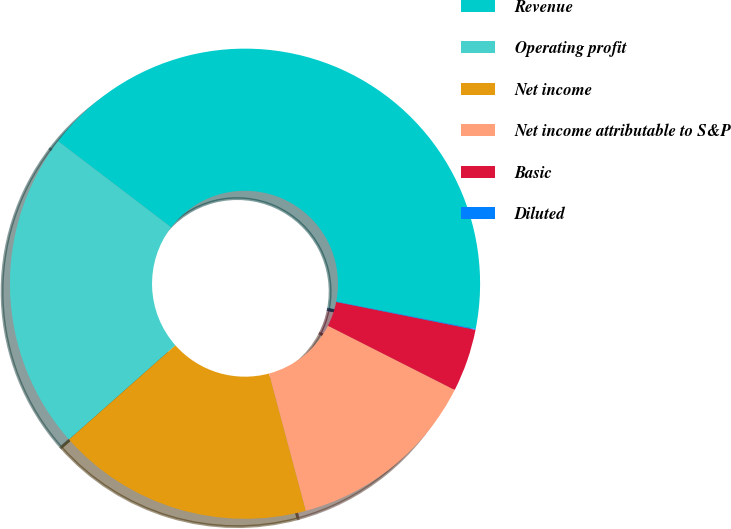<chart> <loc_0><loc_0><loc_500><loc_500><pie_chart><fcel>Revenue<fcel>Operating profit<fcel>Net income<fcel>Net income attributable to S&P<fcel>Basic<fcel>Diluted<nl><fcel>42.72%<fcel>21.9%<fcel>17.63%<fcel>13.37%<fcel>4.32%<fcel>0.05%<nl></chart> 